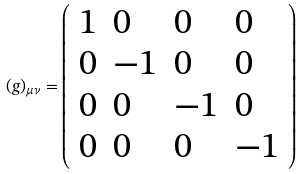<formula> <loc_0><loc_0><loc_500><loc_500>( g ) _ { \mu \nu } = \left ( \begin{array} { l l l l } { 1 } & { 0 } & { 0 } & { 0 } \\ { 0 } & { - 1 } & { 0 } & { 0 } \\ { 0 } & { 0 } & { - 1 } & { 0 } \\ { 0 } & { 0 } & { 0 } & { - 1 } \end{array} \right )</formula> 